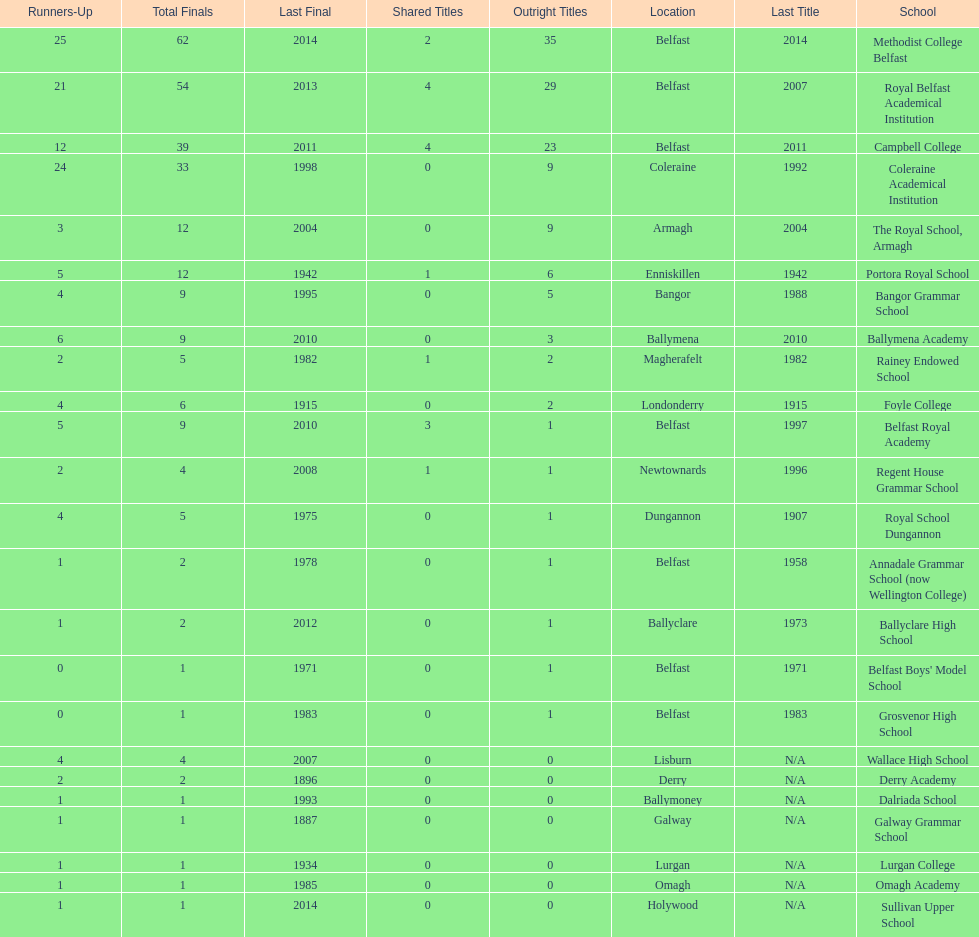Which school has the same number of outright titles as the coleraine academical institution? The Royal School, Armagh. 